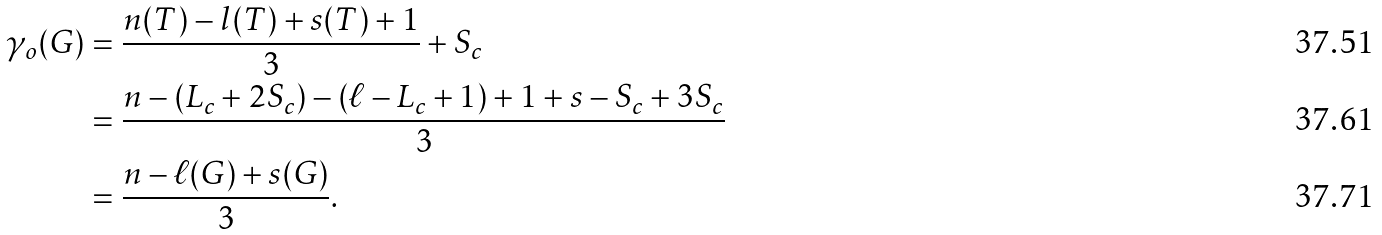Convert formula to latex. <formula><loc_0><loc_0><loc_500><loc_500>\gamma _ { o } ( G ) & = \frac { n ( T ) - l ( T ) + s ( T ) + 1 } { 3 } + S _ { c } \\ & = \frac { n - ( L _ { c } + 2 S _ { c } ) - \left ( \ell - L _ { c } + 1 \right ) + 1 + s - S _ { c } + 3 S _ { c } } { 3 } \\ & = \frac { n - \ell ( G ) + s ( G ) } { 3 } .</formula> 